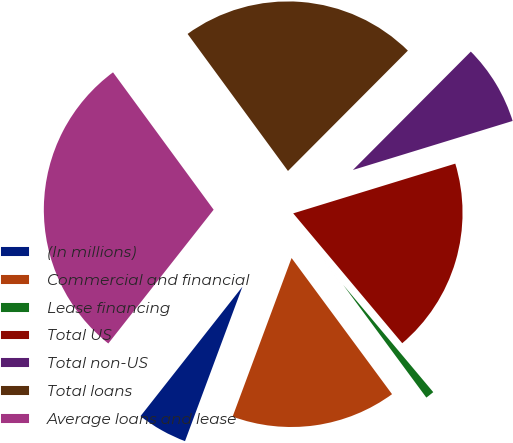<chart> <loc_0><loc_0><loc_500><loc_500><pie_chart><fcel>(In millions)<fcel>Commercial and financial<fcel>Lease financing<fcel>Total US<fcel>Total non-US<fcel>Total loans<fcel>Average loans and lease<nl><fcel>4.95%<fcel>15.78%<fcel>1.0%<fcel>18.62%<fcel>7.79%<fcel>22.53%<fcel>29.32%<nl></chart> 